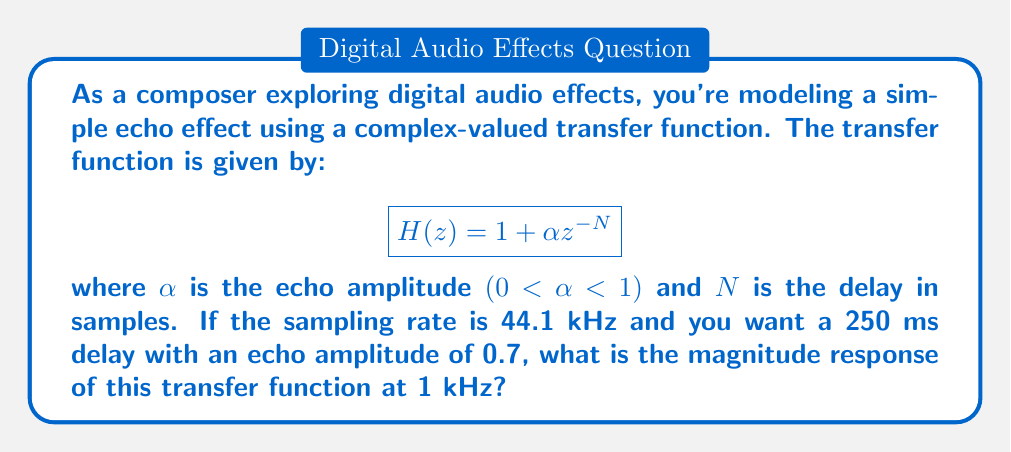Can you solve this math problem? Let's approach this step-by-step:

1) First, we need to calculate N, the delay in samples:
   $$N = \text{delay time} \times \text{sampling rate} = 0.250 \text{ s} \times 44100 \text{ Hz} = 11025 \text{ samples}$$

2) Now, we have $H(z) = 1 + 0.7z^{-11025}$

3) To find the magnitude response at 1 kHz, we need to evaluate $|H(e^{j\omega})|$ where $\omega = 2\pi f / f_s$:
   $$\omega = 2\pi \times 1000 / 44100 \approx 0.1425 \text{ rad/sample}$$

4) Substituting this into our transfer function:
   $$H(e^{j\omega}) = 1 + 0.7e^{-j\omega 11025}$$

5) The magnitude of this complex number is given by:
   $$|H(e^{j\omega})| = \sqrt{(1 + 0.7\cos(\omega 11025))^2 + (0.7\sin(\omega 11025))^2}$$

6) Substituting our $\omega$ value:
   $$|H(e^{j\omega})| = \sqrt{(1 + 0.7\cos(0.1425 \times 11025))^2 + (0.7\sin(0.1425 \times 11025))^2}$$

7) Calculating:
   $$|H(e^{j\omega})| \approx \sqrt{(1 + 0.7\cos(1571.0625))^2 + (0.7\sin(1571.0625))^2}$$
   $$\approx \sqrt{(1 + 0.7 \times 0.0004)^2 + (0.7 \times 0.9999)^2}$$
   $$\approx \sqrt{1.00056 + 0.49}$$
   $$\approx 1.2247$$
Answer: 1.2247 